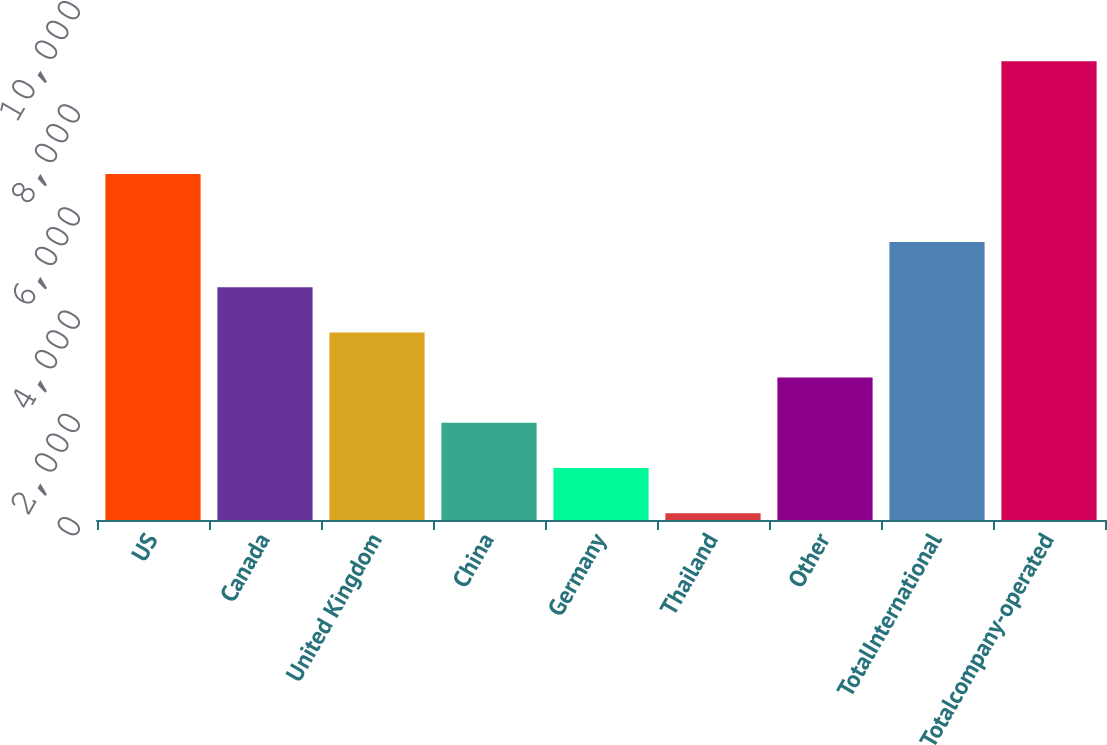Convert chart. <chart><loc_0><loc_0><loc_500><loc_500><bar_chart><fcel>US<fcel>Canada<fcel>United Kingdom<fcel>China<fcel>Germany<fcel>Thailand<fcel>Other<fcel>TotalInternational<fcel>Totalcompany-operated<nl><fcel>6707<fcel>4511<fcel>3635.4<fcel>1884.2<fcel>1008.6<fcel>133<fcel>2759.8<fcel>5386.6<fcel>8889<nl></chart> 